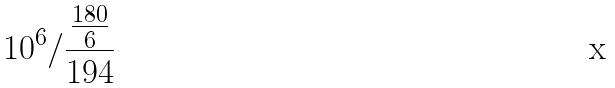Convert formula to latex. <formula><loc_0><loc_0><loc_500><loc_500>1 0 ^ { 6 } / \frac { \frac { 1 8 0 } { 6 } } { 1 9 4 }</formula> 